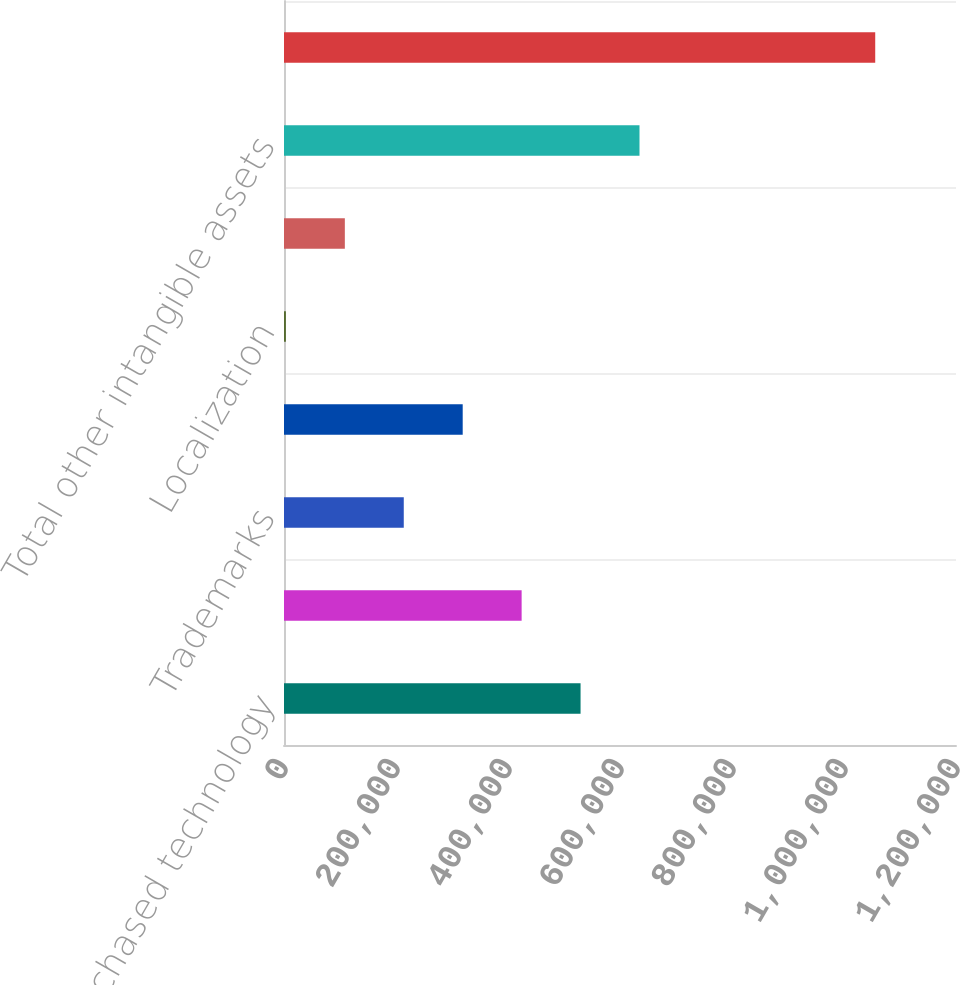Convert chart. <chart><loc_0><loc_0><loc_500><loc_500><bar_chart><fcel>Purchased technology<fcel>Customer contracts and<fcel>Trademarks<fcel>Acquired rights to use<fcel>Localization<fcel>Other intangibles<fcel>Total other intangible assets<fcel>Purchased and other intangible<nl><fcel>529580<fcel>424345<fcel>213874<fcel>319110<fcel>3404<fcel>108639<fcel>634815<fcel>1.05576e+06<nl></chart> 